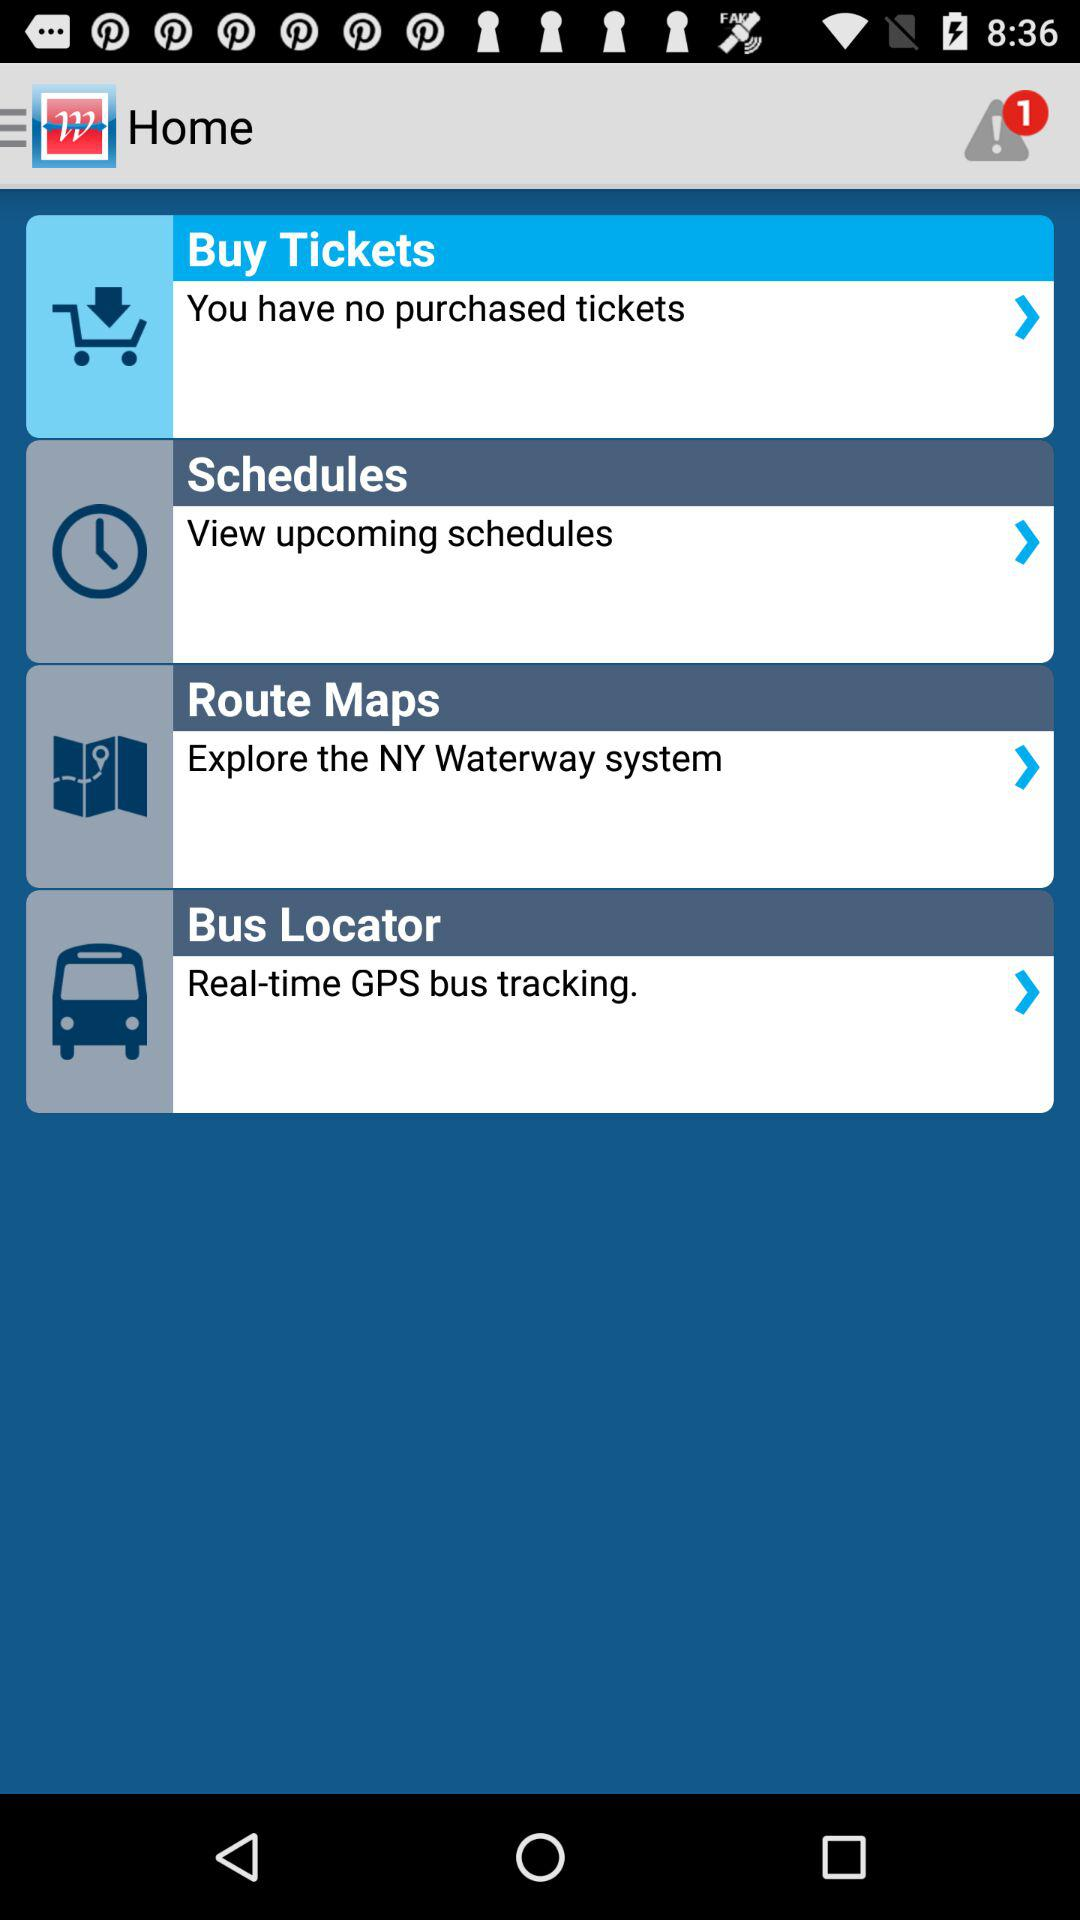Are there any purchased tickets? There are no purchased tickets. 